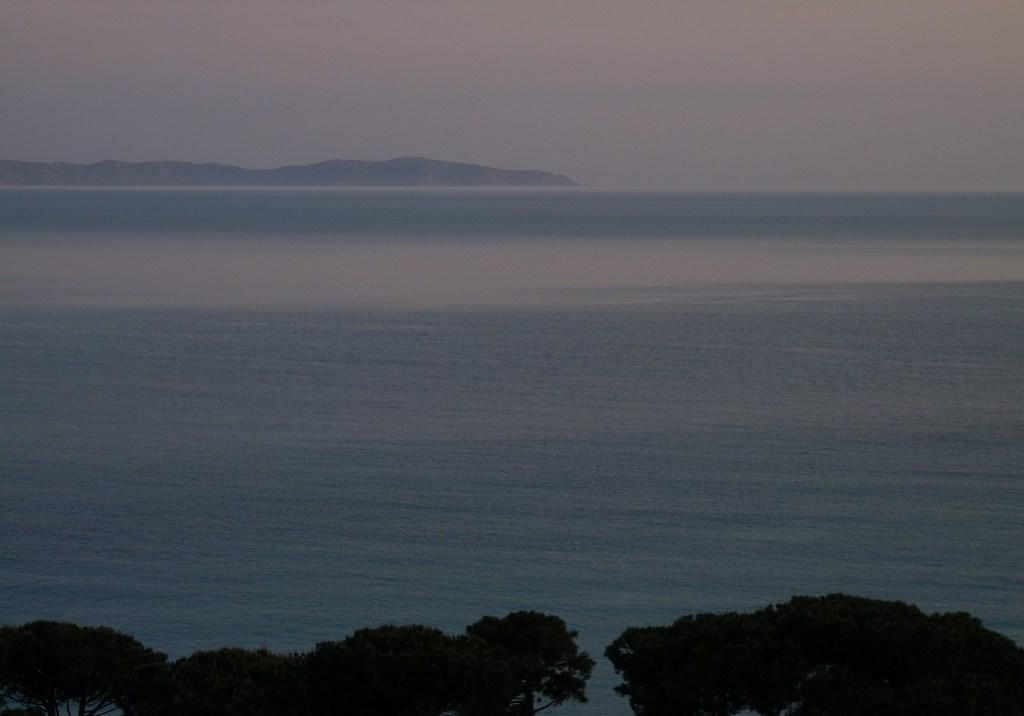What is the main subject of the image? The main subject of the image is a beautiful view of the sea water. What can be seen at the bottom of the image? There are trees visible at the front bottom side of the image. What other natural features can be seen in the background? There are mountains visible in the background of the image. What is the rate of the waves crashing on the shore? There is no information provided about the rate of the waves crashing on the shore, so it cannot be determined. 